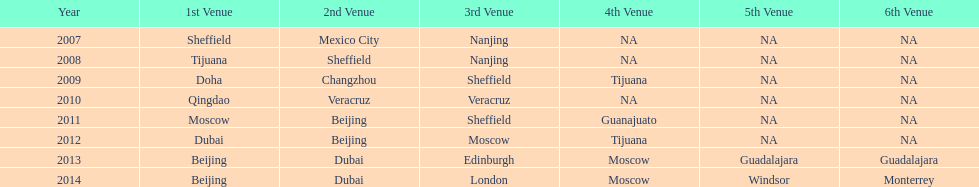Between 2007 and 2012, which year had a greater number of venues? 2012. 